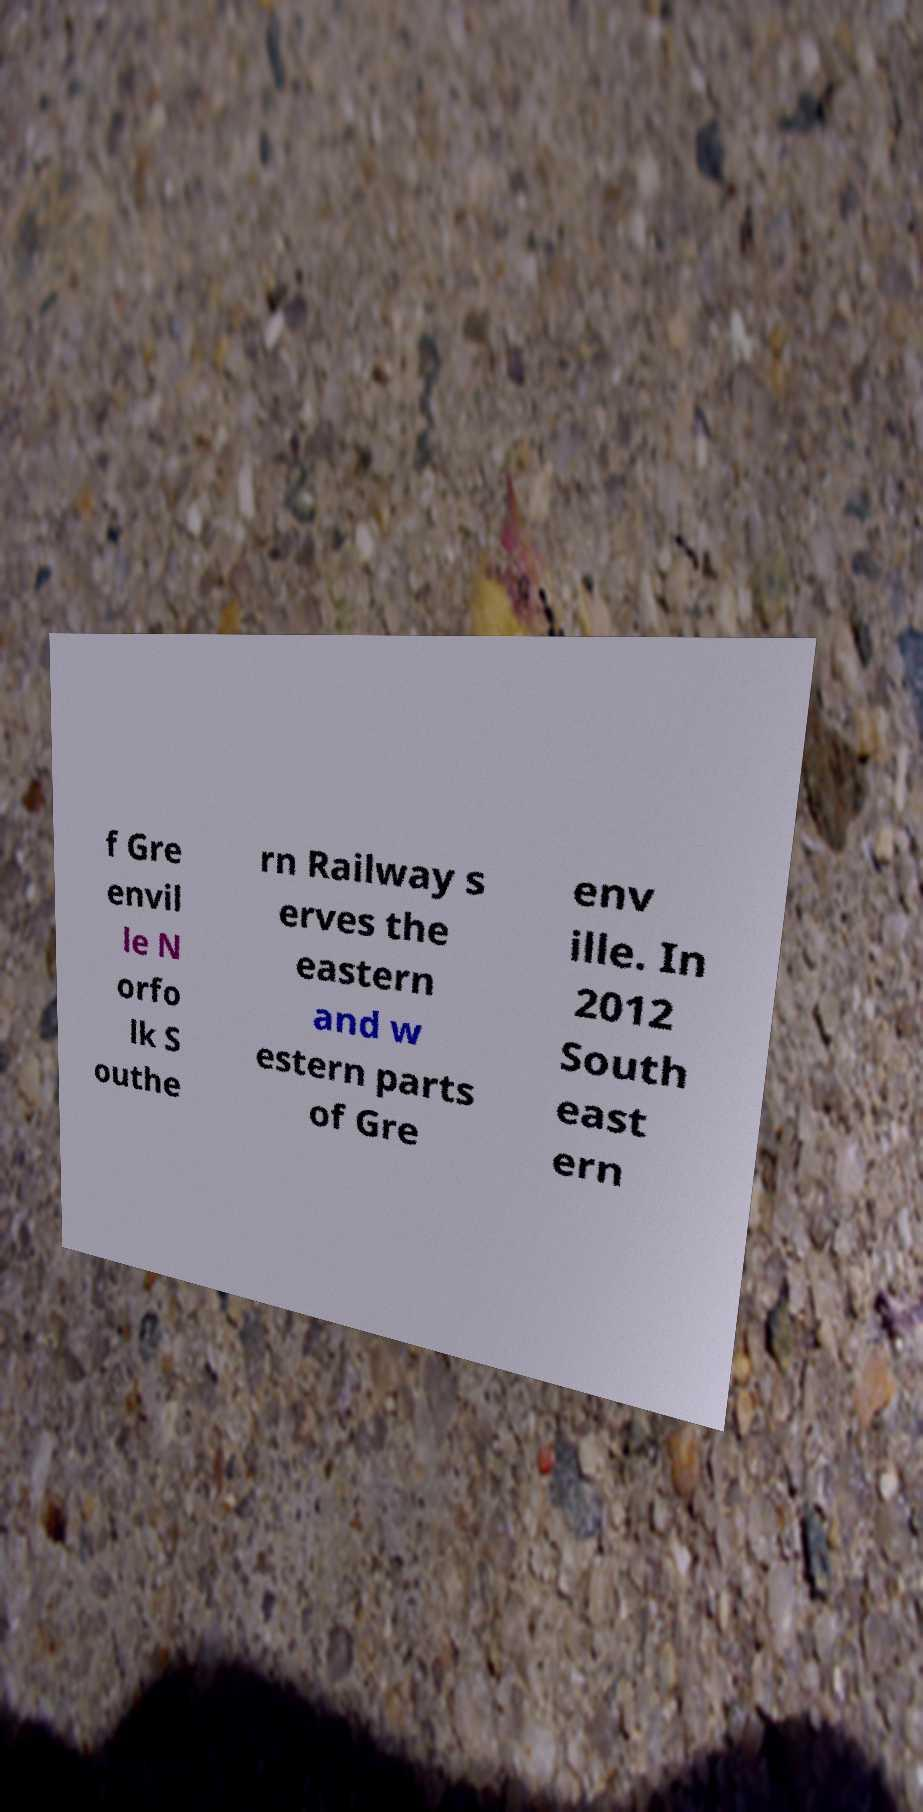Please identify and transcribe the text found in this image. f Gre envil le N orfo lk S outhe rn Railway s erves the eastern and w estern parts of Gre env ille. In 2012 South east ern 